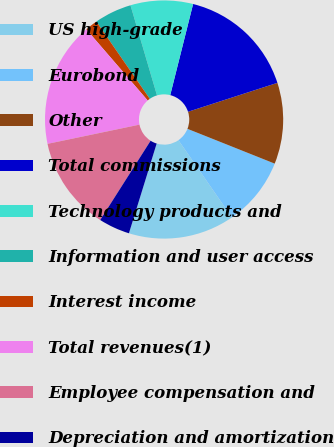<chart> <loc_0><loc_0><loc_500><loc_500><pie_chart><fcel>US high-grade<fcel>Eurobond<fcel>Other<fcel>Total commissions<fcel>Technology products and<fcel>Information and user access<fcel>Interest income<fcel>Total revenues(1)<fcel>Employee compensation and<fcel>Depreciation and amortization<nl><fcel>14.41%<fcel>9.32%<fcel>11.02%<fcel>16.1%<fcel>8.47%<fcel>5.08%<fcel>1.69%<fcel>16.95%<fcel>12.71%<fcel>4.24%<nl></chart> 